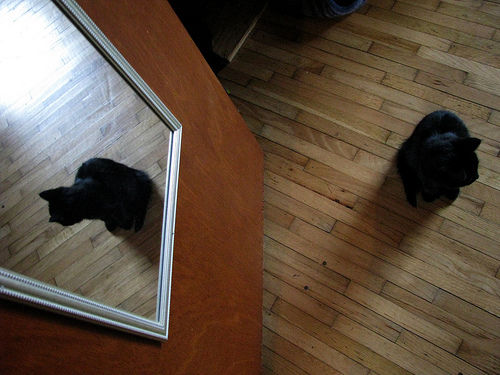<image>
Can you confirm if the mirror is to the right of the cat? Yes. From this viewpoint, the mirror is positioned to the right side relative to the cat. 